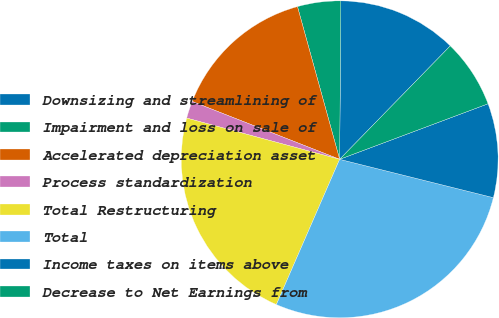<chart> <loc_0><loc_0><loc_500><loc_500><pie_chart><fcel>Downsizing and streamlining of<fcel>Impairment and loss on sale of<fcel>Accelerated depreciation asset<fcel>Process standardization<fcel>Total Restructuring<fcel>Total<fcel>Income taxes on items above<fcel>Decrease to Net Earnings from<nl><fcel>12.18%<fcel>4.41%<fcel>14.76%<fcel>1.76%<fcel>22.65%<fcel>27.65%<fcel>9.59%<fcel>7.0%<nl></chart> 